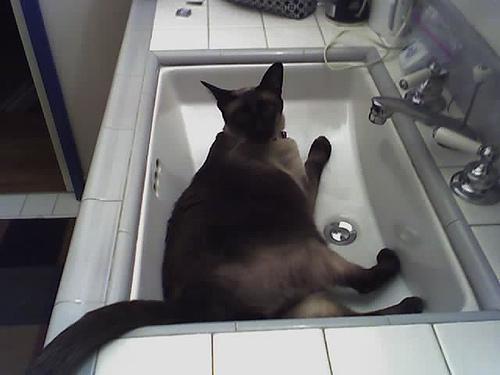How many people carry umbrellas?
Give a very brief answer. 0. 